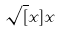<formula> <loc_0><loc_0><loc_500><loc_500>\sqrt { [ } x ] { x }</formula> 